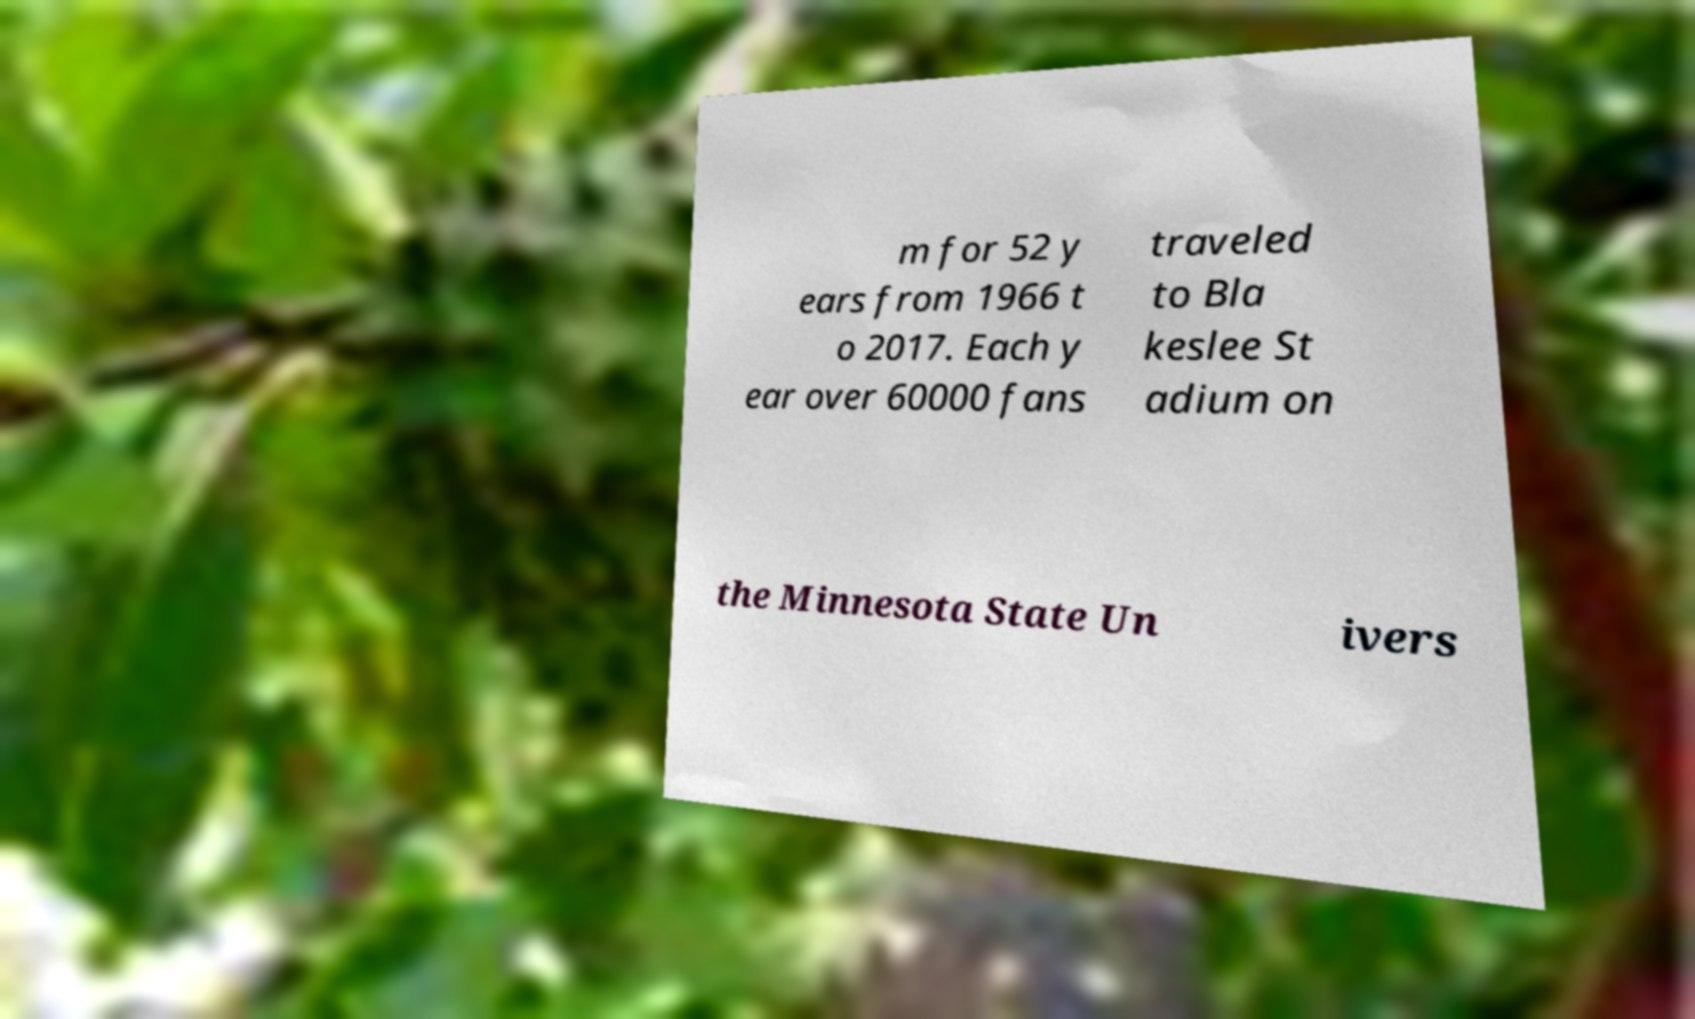What messages or text are displayed in this image? I need them in a readable, typed format. m for 52 y ears from 1966 t o 2017. Each y ear over 60000 fans traveled to Bla keslee St adium on the Minnesota State Un ivers 